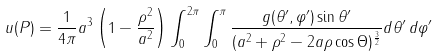Convert formula to latex. <formula><loc_0><loc_0><loc_500><loc_500>u ( P ) = { \frac { 1 } { 4 \pi } } a ^ { 3 } \left ( 1 - { \frac { \rho ^ { 2 } } { a ^ { 2 } } } \right ) \int _ { 0 } ^ { 2 \pi } \int _ { 0 } ^ { \pi } { \frac { g ( \theta ^ { \prime } , \varphi ^ { \prime } ) \sin \theta ^ { \prime } } { ( a ^ { 2 } + \rho ^ { 2 } - 2 a \rho \cos \Theta ) ^ { \frac { 3 } { 2 } } } } d \theta ^ { \prime } \, d \varphi ^ { \prime }</formula> 